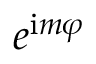<formula> <loc_0><loc_0><loc_500><loc_500>e ^ { i m \varphi }</formula> 